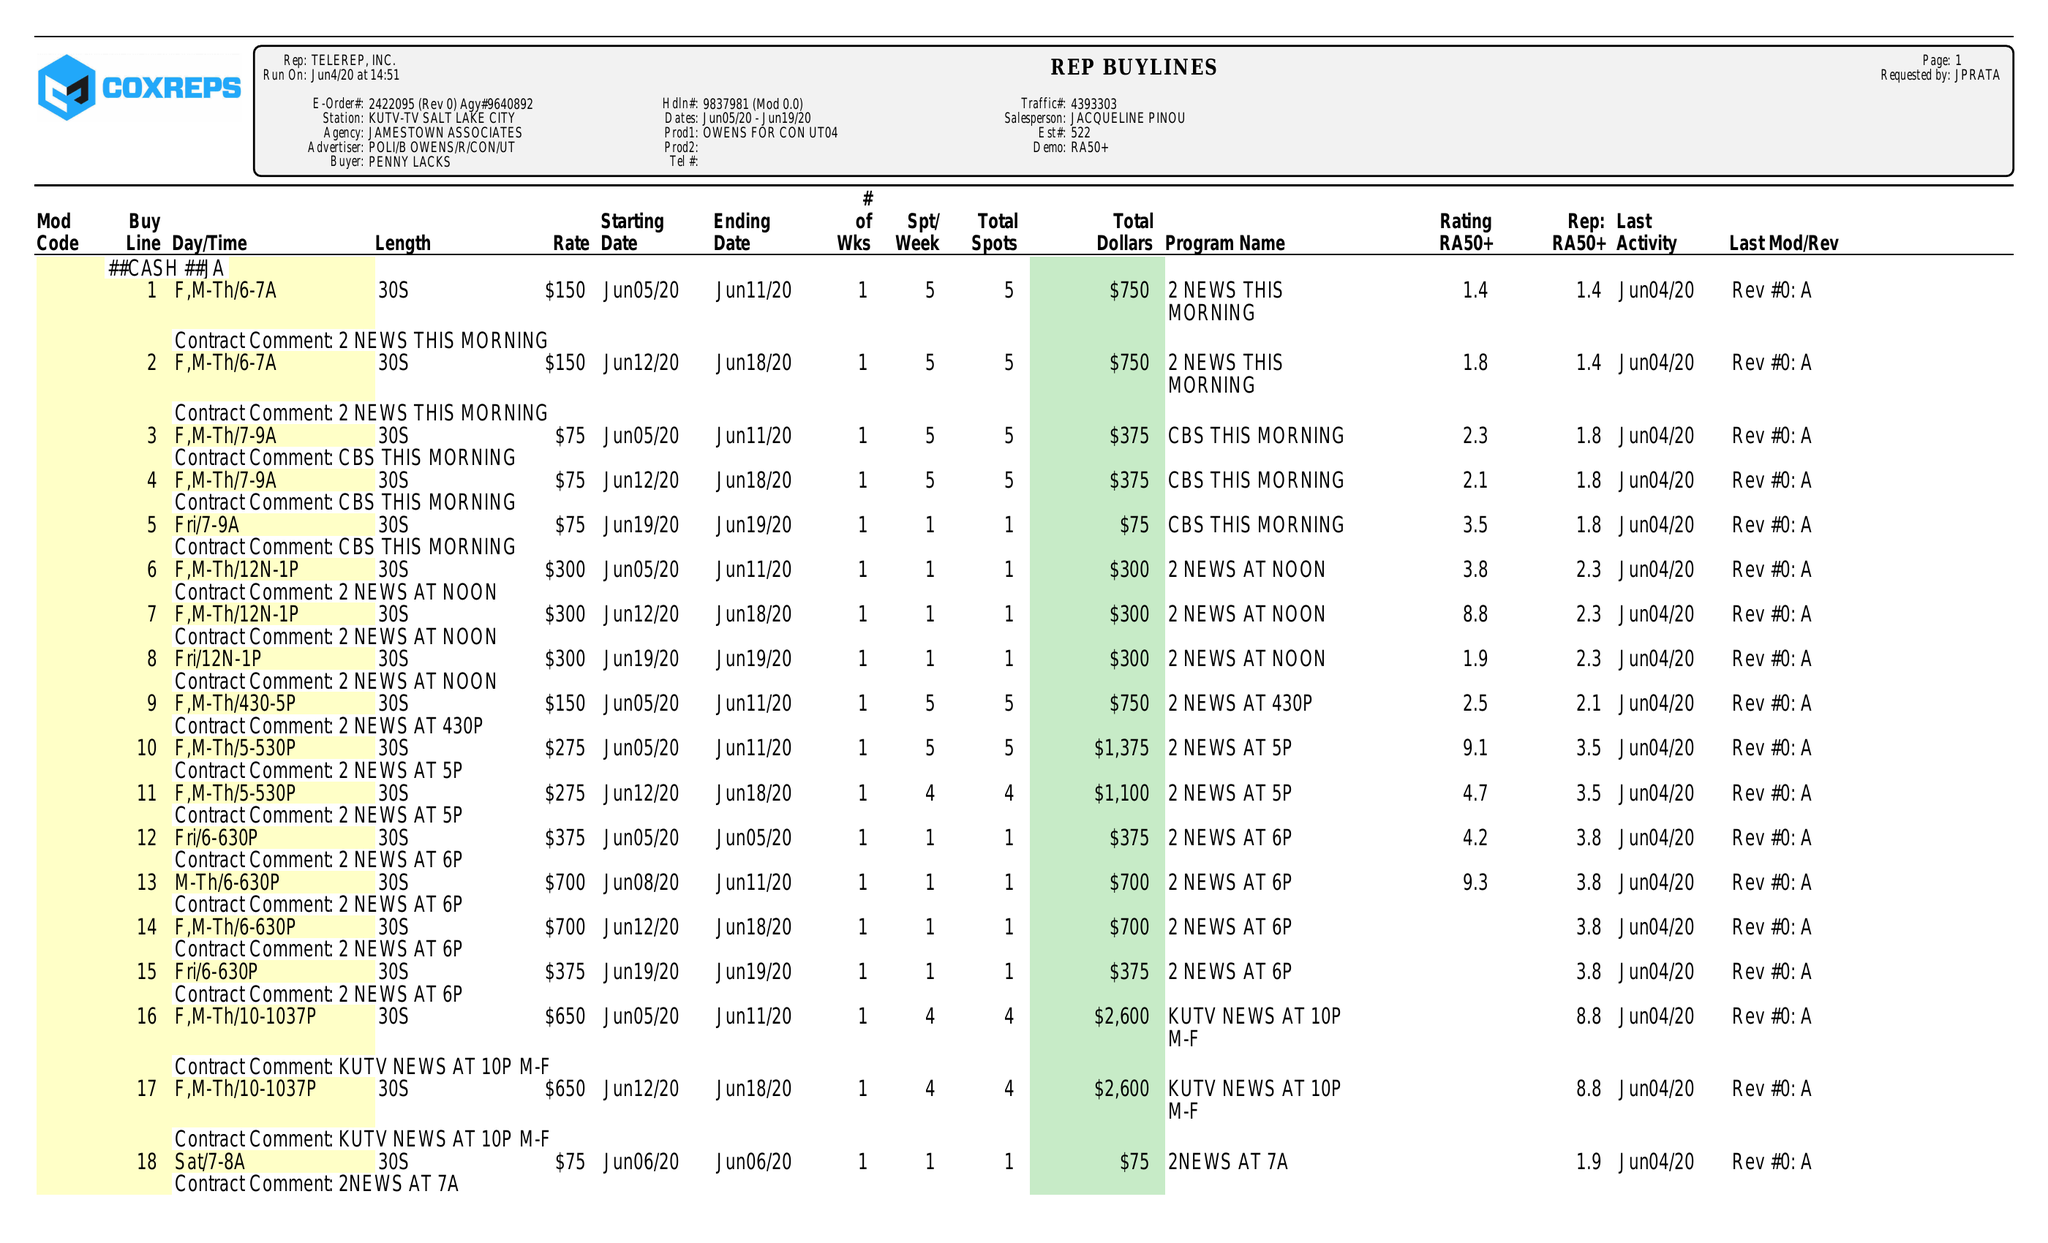What is the value for the gross_amount?
Answer the question using a single word or phrase. 16675.00 